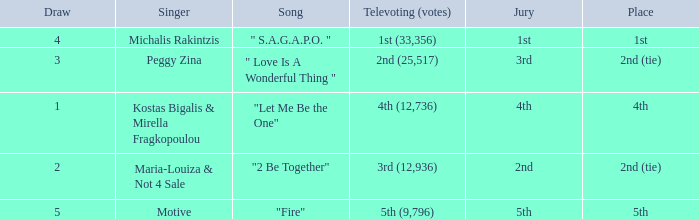The song "2 Be Together" had what jury? 2nd. 